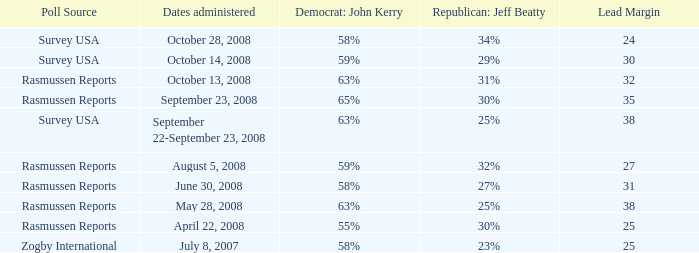What percent is the lead margin of 25 that Republican: Jeff Beatty has according to poll source Rasmussen Reports? 30%. 